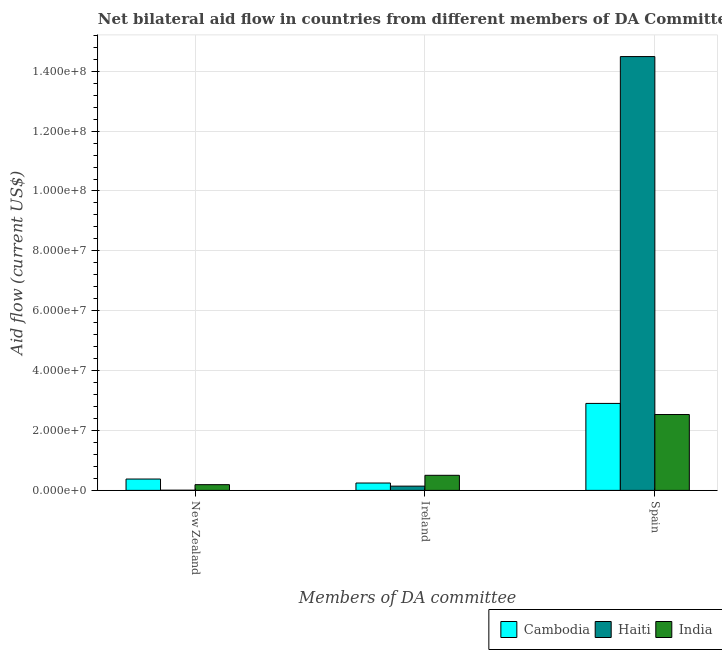How many groups of bars are there?
Provide a short and direct response. 3. Are the number of bars per tick equal to the number of legend labels?
Ensure brevity in your answer.  Yes. What is the label of the 2nd group of bars from the left?
Keep it short and to the point. Ireland. What is the amount of aid provided by spain in Haiti?
Provide a short and direct response. 1.45e+08. Across all countries, what is the maximum amount of aid provided by ireland?
Provide a short and direct response. 5.04e+06. Across all countries, what is the minimum amount of aid provided by spain?
Your answer should be compact. 2.53e+07. In which country was the amount of aid provided by new zealand maximum?
Make the answer very short. Cambodia. In which country was the amount of aid provided by spain minimum?
Your response must be concise. India. What is the total amount of aid provided by spain in the graph?
Make the answer very short. 1.99e+08. What is the difference between the amount of aid provided by new zealand in India and that in Cambodia?
Ensure brevity in your answer.  -1.88e+06. What is the difference between the amount of aid provided by ireland in India and the amount of aid provided by new zealand in Haiti?
Ensure brevity in your answer.  4.98e+06. What is the average amount of aid provided by new zealand per country?
Make the answer very short. 1.92e+06. What is the difference between the amount of aid provided by new zealand and amount of aid provided by spain in India?
Make the answer very short. -2.34e+07. In how many countries, is the amount of aid provided by ireland greater than 128000000 US$?
Offer a terse response. 0. What is the ratio of the amount of aid provided by new zealand in India to that in Cambodia?
Your response must be concise. 0.5. Is the amount of aid provided by spain in Haiti less than that in Cambodia?
Your answer should be compact. No. What is the difference between the highest and the second highest amount of aid provided by new zealand?
Ensure brevity in your answer.  1.88e+06. What is the difference between the highest and the lowest amount of aid provided by ireland?
Provide a succinct answer. 3.62e+06. In how many countries, is the amount of aid provided by new zealand greater than the average amount of aid provided by new zealand taken over all countries?
Offer a very short reply. 1. What does the 2nd bar from the left in Ireland represents?
Offer a very short reply. Haiti. What does the 2nd bar from the right in New Zealand represents?
Offer a very short reply. Haiti. How many bars are there?
Provide a succinct answer. 9. Are all the bars in the graph horizontal?
Keep it short and to the point. No. Does the graph contain any zero values?
Your answer should be compact. No. Does the graph contain grids?
Provide a succinct answer. Yes. What is the title of the graph?
Your answer should be compact. Net bilateral aid flow in countries from different members of DA Committee. What is the label or title of the X-axis?
Your answer should be very brief. Members of DA committee. What is the Aid flow (current US$) of Cambodia in New Zealand?
Offer a very short reply. 3.79e+06. What is the Aid flow (current US$) of Haiti in New Zealand?
Your response must be concise. 6.00e+04. What is the Aid flow (current US$) in India in New Zealand?
Your answer should be very brief. 1.91e+06. What is the Aid flow (current US$) in Cambodia in Ireland?
Make the answer very short. 2.46e+06. What is the Aid flow (current US$) in Haiti in Ireland?
Keep it short and to the point. 1.42e+06. What is the Aid flow (current US$) of India in Ireland?
Ensure brevity in your answer.  5.04e+06. What is the Aid flow (current US$) in Cambodia in Spain?
Offer a very short reply. 2.90e+07. What is the Aid flow (current US$) of Haiti in Spain?
Your answer should be very brief. 1.45e+08. What is the Aid flow (current US$) in India in Spain?
Make the answer very short. 2.53e+07. Across all Members of DA committee, what is the maximum Aid flow (current US$) of Cambodia?
Provide a succinct answer. 2.90e+07. Across all Members of DA committee, what is the maximum Aid flow (current US$) of Haiti?
Your response must be concise. 1.45e+08. Across all Members of DA committee, what is the maximum Aid flow (current US$) of India?
Offer a very short reply. 2.53e+07. Across all Members of DA committee, what is the minimum Aid flow (current US$) of Cambodia?
Your response must be concise. 2.46e+06. Across all Members of DA committee, what is the minimum Aid flow (current US$) of Haiti?
Keep it short and to the point. 6.00e+04. Across all Members of DA committee, what is the minimum Aid flow (current US$) of India?
Provide a succinct answer. 1.91e+06. What is the total Aid flow (current US$) of Cambodia in the graph?
Provide a succinct answer. 3.53e+07. What is the total Aid flow (current US$) of Haiti in the graph?
Your answer should be compact. 1.46e+08. What is the total Aid flow (current US$) in India in the graph?
Offer a very short reply. 3.23e+07. What is the difference between the Aid flow (current US$) of Cambodia in New Zealand and that in Ireland?
Provide a short and direct response. 1.33e+06. What is the difference between the Aid flow (current US$) of Haiti in New Zealand and that in Ireland?
Your answer should be compact. -1.36e+06. What is the difference between the Aid flow (current US$) of India in New Zealand and that in Ireland?
Keep it short and to the point. -3.13e+06. What is the difference between the Aid flow (current US$) in Cambodia in New Zealand and that in Spain?
Provide a short and direct response. -2.53e+07. What is the difference between the Aid flow (current US$) of Haiti in New Zealand and that in Spain?
Offer a very short reply. -1.45e+08. What is the difference between the Aid flow (current US$) in India in New Zealand and that in Spain?
Offer a very short reply. -2.34e+07. What is the difference between the Aid flow (current US$) of Cambodia in Ireland and that in Spain?
Offer a very short reply. -2.66e+07. What is the difference between the Aid flow (current US$) in Haiti in Ireland and that in Spain?
Provide a succinct answer. -1.43e+08. What is the difference between the Aid flow (current US$) of India in Ireland and that in Spain?
Make the answer very short. -2.03e+07. What is the difference between the Aid flow (current US$) of Cambodia in New Zealand and the Aid flow (current US$) of Haiti in Ireland?
Ensure brevity in your answer.  2.37e+06. What is the difference between the Aid flow (current US$) in Cambodia in New Zealand and the Aid flow (current US$) in India in Ireland?
Your response must be concise. -1.25e+06. What is the difference between the Aid flow (current US$) in Haiti in New Zealand and the Aid flow (current US$) in India in Ireland?
Your answer should be very brief. -4.98e+06. What is the difference between the Aid flow (current US$) in Cambodia in New Zealand and the Aid flow (current US$) in Haiti in Spain?
Give a very brief answer. -1.41e+08. What is the difference between the Aid flow (current US$) of Cambodia in New Zealand and the Aid flow (current US$) of India in Spain?
Your answer should be very brief. -2.16e+07. What is the difference between the Aid flow (current US$) of Haiti in New Zealand and the Aid flow (current US$) of India in Spain?
Offer a very short reply. -2.53e+07. What is the difference between the Aid flow (current US$) in Cambodia in Ireland and the Aid flow (current US$) in Haiti in Spain?
Your response must be concise. -1.42e+08. What is the difference between the Aid flow (current US$) in Cambodia in Ireland and the Aid flow (current US$) in India in Spain?
Offer a terse response. -2.29e+07. What is the difference between the Aid flow (current US$) of Haiti in Ireland and the Aid flow (current US$) of India in Spain?
Provide a short and direct response. -2.39e+07. What is the average Aid flow (current US$) in Cambodia per Members of DA committee?
Offer a terse response. 1.18e+07. What is the average Aid flow (current US$) of Haiti per Members of DA committee?
Ensure brevity in your answer.  4.88e+07. What is the average Aid flow (current US$) of India per Members of DA committee?
Your answer should be very brief. 1.08e+07. What is the difference between the Aid flow (current US$) in Cambodia and Aid flow (current US$) in Haiti in New Zealand?
Give a very brief answer. 3.73e+06. What is the difference between the Aid flow (current US$) in Cambodia and Aid flow (current US$) in India in New Zealand?
Offer a terse response. 1.88e+06. What is the difference between the Aid flow (current US$) in Haiti and Aid flow (current US$) in India in New Zealand?
Give a very brief answer. -1.85e+06. What is the difference between the Aid flow (current US$) in Cambodia and Aid flow (current US$) in Haiti in Ireland?
Ensure brevity in your answer.  1.04e+06. What is the difference between the Aid flow (current US$) in Cambodia and Aid flow (current US$) in India in Ireland?
Provide a succinct answer. -2.58e+06. What is the difference between the Aid flow (current US$) in Haiti and Aid flow (current US$) in India in Ireland?
Offer a very short reply. -3.62e+06. What is the difference between the Aid flow (current US$) in Cambodia and Aid flow (current US$) in Haiti in Spain?
Your answer should be compact. -1.16e+08. What is the difference between the Aid flow (current US$) in Cambodia and Aid flow (current US$) in India in Spain?
Provide a short and direct response. 3.71e+06. What is the difference between the Aid flow (current US$) of Haiti and Aid flow (current US$) of India in Spain?
Make the answer very short. 1.20e+08. What is the ratio of the Aid flow (current US$) of Cambodia in New Zealand to that in Ireland?
Keep it short and to the point. 1.54. What is the ratio of the Aid flow (current US$) of Haiti in New Zealand to that in Ireland?
Offer a terse response. 0.04. What is the ratio of the Aid flow (current US$) of India in New Zealand to that in Ireland?
Give a very brief answer. 0.38. What is the ratio of the Aid flow (current US$) in Cambodia in New Zealand to that in Spain?
Provide a short and direct response. 0.13. What is the ratio of the Aid flow (current US$) in Haiti in New Zealand to that in Spain?
Your answer should be compact. 0. What is the ratio of the Aid flow (current US$) in India in New Zealand to that in Spain?
Give a very brief answer. 0.08. What is the ratio of the Aid flow (current US$) in Cambodia in Ireland to that in Spain?
Offer a very short reply. 0.08. What is the ratio of the Aid flow (current US$) in Haiti in Ireland to that in Spain?
Provide a short and direct response. 0.01. What is the ratio of the Aid flow (current US$) in India in Ireland to that in Spain?
Provide a succinct answer. 0.2. What is the difference between the highest and the second highest Aid flow (current US$) in Cambodia?
Your answer should be very brief. 2.53e+07. What is the difference between the highest and the second highest Aid flow (current US$) in Haiti?
Offer a terse response. 1.43e+08. What is the difference between the highest and the second highest Aid flow (current US$) in India?
Keep it short and to the point. 2.03e+07. What is the difference between the highest and the lowest Aid flow (current US$) of Cambodia?
Provide a succinct answer. 2.66e+07. What is the difference between the highest and the lowest Aid flow (current US$) of Haiti?
Provide a short and direct response. 1.45e+08. What is the difference between the highest and the lowest Aid flow (current US$) in India?
Ensure brevity in your answer.  2.34e+07. 